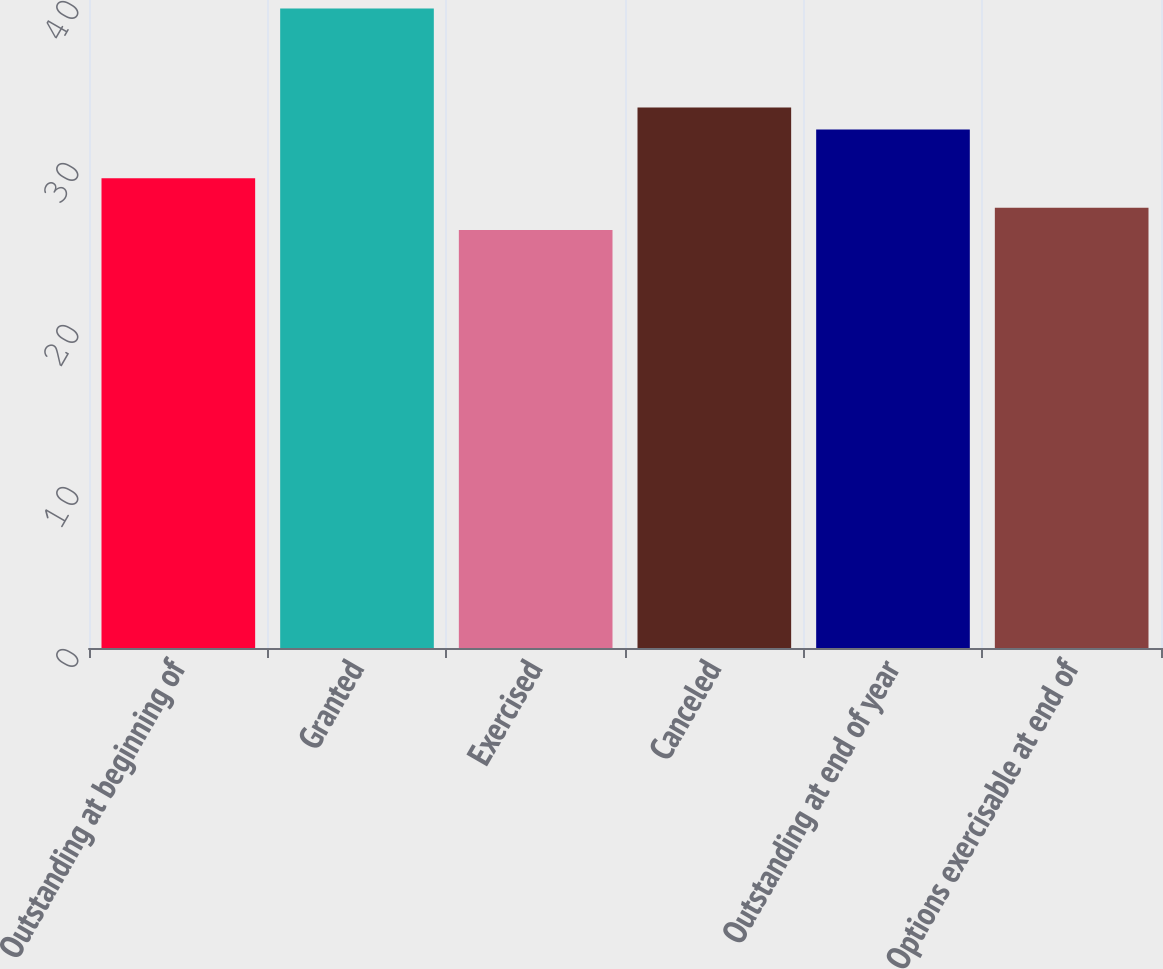Convert chart. <chart><loc_0><loc_0><loc_500><loc_500><bar_chart><fcel>Outstanding at beginning of<fcel>Granted<fcel>Exercised<fcel>Canceled<fcel>Outstanding at end of year<fcel>Options exercisable at end of<nl><fcel>29<fcel>39.47<fcel>25.8<fcel>33.37<fcel>32<fcel>27.17<nl></chart> 